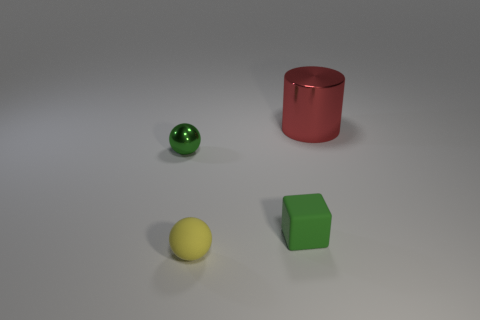Add 2 small green balls. How many objects exist? 6 Subtract all cylinders. How many objects are left? 3 Subtract 0 blue blocks. How many objects are left? 4 Subtract all small yellow objects. Subtract all small brown spheres. How many objects are left? 3 Add 4 yellow matte objects. How many yellow matte objects are left? 5 Add 3 matte objects. How many matte objects exist? 5 